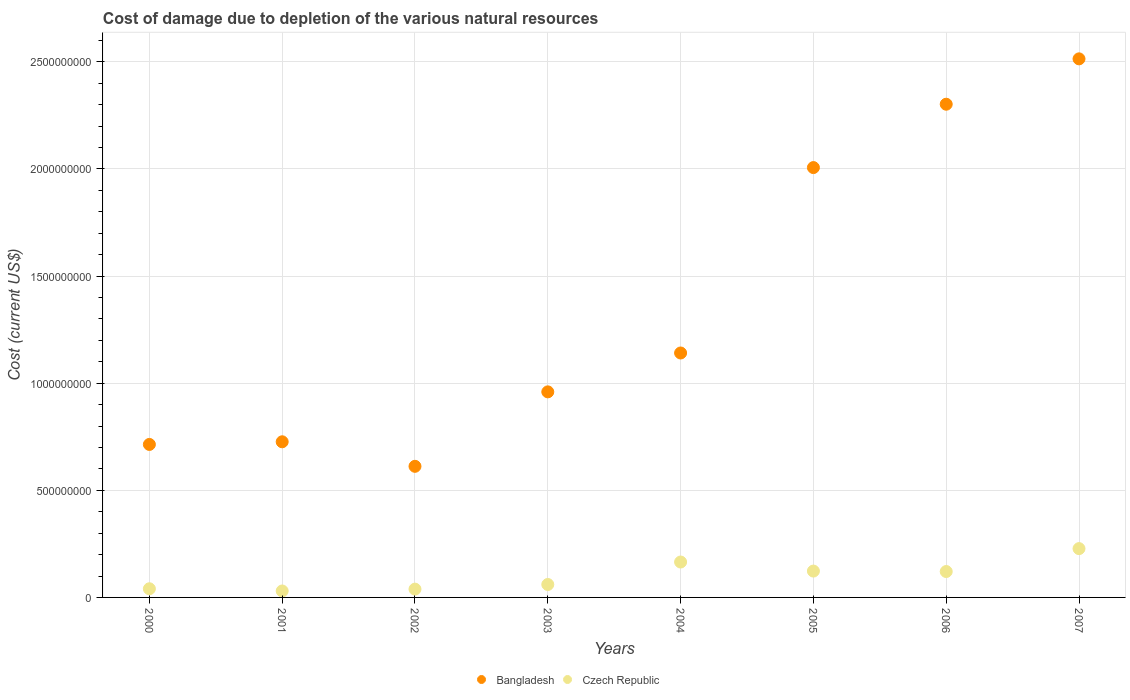Is the number of dotlines equal to the number of legend labels?
Offer a very short reply. Yes. What is the cost of damage caused due to the depletion of various natural resources in Czech Republic in 2006?
Offer a very short reply. 1.21e+08. Across all years, what is the maximum cost of damage caused due to the depletion of various natural resources in Czech Republic?
Give a very brief answer. 2.28e+08. Across all years, what is the minimum cost of damage caused due to the depletion of various natural resources in Czech Republic?
Your response must be concise. 3.01e+07. What is the total cost of damage caused due to the depletion of various natural resources in Bangladesh in the graph?
Offer a terse response. 1.10e+1. What is the difference between the cost of damage caused due to the depletion of various natural resources in Bangladesh in 2006 and that in 2007?
Ensure brevity in your answer.  -2.12e+08. What is the difference between the cost of damage caused due to the depletion of various natural resources in Czech Republic in 2002 and the cost of damage caused due to the depletion of various natural resources in Bangladesh in 2007?
Offer a very short reply. -2.48e+09. What is the average cost of damage caused due to the depletion of various natural resources in Czech Republic per year?
Your answer should be very brief. 1.01e+08. In the year 2007, what is the difference between the cost of damage caused due to the depletion of various natural resources in Czech Republic and cost of damage caused due to the depletion of various natural resources in Bangladesh?
Keep it short and to the point. -2.29e+09. What is the ratio of the cost of damage caused due to the depletion of various natural resources in Bangladesh in 2001 to that in 2002?
Your answer should be very brief. 1.19. Is the difference between the cost of damage caused due to the depletion of various natural resources in Czech Republic in 2002 and 2006 greater than the difference between the cost of damage caused due to the depletion of various natural resources in Bangladesh in 2002 and 2006?
Your response must be concise. Yes. What is the difference between the highest and the second highest cost of damage caused due to the depletion of various natural resources in Bangladesh?
Offer a very short reply. 2.12e+08. What is the difference between the highest and the lowest cost of damage caused due to the depletion of various natural resources in Czech Republic?
Your answer should be compact. 1.98e+08. In how many years, is the cost of damage caused due to the depletion of various natural resources in Czech Republic greater than the average cost of damage caused due to the depletion of various natural resources in Czech Republic taken over all years?
Ensure brevity in your answer.  4. Does the cost of damage caused due to the depletion of various natural resources in Czech Republic monotonically increase over the years?
Keep it short and to the point. No. Is the cost of damage caused due to the depletion of various natural resources in Bangladesh strictly greater than the cost of damage caused due to the depletion of various natural resources in Czech Republic over the years?
Your answer should be compact. Yes. What is the difference between two consecutive major ticks on the Y-axis?
Make the answer very short. 5.00e+08. Are the values on the major ticks of Y-axis written in scientific E-notation?
Provide a succinct answer. No. Does the graph contain any zero values?
Provide a succinct answer. No. Does the graph contain grids?
Offer a very short reply. Yes. How are the legend labels stacked?
Offer a terse response. Horizontal. What is the title of the graph?
Ensure brevity in your answer.  Cost of damage due to depletion of the various natural resources. What is the label or title of the X-axis?
Provide a succinct answer. Years. What is the label or title of the Y-axis?
Ensure brevity in your answer.  Cost (current US$). What is the Cost (current US$) of Bangladesh in 2000?
Make the answer very short. 7.14e+08. What is the Cost (current US$) of Czech Republic in 2000?
Make the answer very short. 4.04e+07. What is the Cost (current US$) in Bangladesh in 2001?
Offer a terse response. 7.27e+08. What is the Cost (current US$) in Czech Republic in 2001?
Offer a terse response. 3.01e+07. What is the Cost (current US$) in Bangladesh in 2002?
Give a very brief answer. 6.12e+08. What is the Cost (current US$) of Czech Republic in 2002?
Provide a short and direct response. 3.87e+07. What is the Cost (current US$) of Bangladesh in 2003?
Offer a very short reply. 9.60e+08. What is the Cost (current US$) of Czech Republic in 2003?
Offer a terse response. 6.04e+07. What is the Cost (current US$) in Bangladesh in 2004?
Your answer should be very brief. 1.14e+09. What is the Cost (current US$) in Czech Republic in 2004?
Provide a succinct answer. 1.65e+08. What is the Cost (current US$) of Bangladesh in 2005?
Make the answer very short. 2.01e+09. What is the Cost (current US$) of Czech Republic in 2005?
Provide a short and direct response. 1.23e+08. What is the Cost (current US$) in Bangladesh in 2006?
Give a very brief answer. 2.30e+09. What is the Cost (current US$) of Czech Republic in 2006?
Offer a very short reply. 1.21e+08. What is the Cost (current US$) of Bangladesh in 2007?
Give a very brief answer. 2.51e+09. What is the Cost (current US$) of Czech Republic in 2007?
Offer a very short reply. 2.28e+08. Across all years, what is the maximum Cost (current US$) in Bangladesh?
Provide a short and direct response. 2.51e+09. Across all years, what is the maximum Cost (current US$) in Czech Republic?
Your answer should be very brief. 2.28e+08. Across all years, what is the minimum Cost (current US$) in Bangladesh?
Give a very brief answer. 6.12e+08. Across all years, what is the minimum Cost (current US$) in Czech Republic?
Your answer should be compact. 3.01e+07. What is the total Cost (current US$) in Bangladesh in the graph?
Ensure brevity in your answer.  1.10e+1. What is the total Cost (current US$) of Czech Republic in the graph?
Give a very brief answer. 8.07e+08. What is the difference between the Cost (current US$) in Bangladesh in 2000 and that in 2001?
Give a very brief answer. -1.23e+07. What is the difference between the Cost (current US$) in Czech Republic in 2000 and that in 2001?
Offer a terse response. 1.03e+07. What is the difference between the Cost (current US$) of Bangladesh in 2000 and that in 2002?
Make the answer very short. 1.02e+08. What is the difference between the Cost (current US$) in Czech Republic in 2000 and that in 2002?
Your answer should be very brief. 1.72e+06. What is the difference between the Cost (current US$) in Bangladesh in 2000 and that in 2003?
Provide a succinct answer. -2.45e+08. What is the difference between the Cost (current US$) of Czech Republic in 2000 and that in 2003?
Provide a short and direct response. -2.00e+07. What is the difference between the Cost (current US$) of Bangladesh in 2000 and that in 2004?
Ensure brevity in your answer.  -4.27e+08. What is the difference between the Cost (current US$) of Czech Republic in 2000 and that in 2004?
Offer a very short reply. -1.25e+08. What is the difference between the Cost (current US$) of Bangladesh in 2000 and that in 2005?
Offer a terse response. -1.29e+09. What is the difference between the Cost (current US$) in Czech Republic in 2000 and that in 2005?
Ensure brevity in your answer.  -8.26e+07. What is the difference between the Cost (current US$) of Bangladesh in 2000 and that in 2006?
Offer a terse response. -1.59e+09. What is the difference between the Cost (current US$) of Czech Republic in 2000 and that in 2006?
Offer a very short reply. -8.05e+07. What is the difference between the Cost (current US$) of Bangladesh in 2000 and that in 2007?
Give a very brief answer. -1.80e+09. What is the difference between the Cost (current US$) in Czech Republic in 2000 and that in 2007?
Your answer should be compact. -1.87e+08. What is the difference between the Cost (current US$) in Bangladesh in 2001 and that in 2002?
Give a very brief answer. 1.15e+08. What is the difference between the Cost (current US$) of Czech Republic in 2001 and that in 2002?
Ensure brevity in your answer.  -8.56e+06. What is the difference between the Cost (current US$) of Bangladesh in 2001 and that in 2003?
Offer a terse response. -2.33e+08. What is the difference between the Cost (current US$) of Czech Republic in 2001 and that in 2003?
Your response must be concise. -3.03e+07. What is the difference between the Cost (current US$) in Bangladesh in 2001 and that in 2004?
Offer a very short reply. -4.15e+08. What is the difference between the Cost (current US$) in Czech Republic in 2001 and that in 2004?
Your answer should be very brief. -1.35e+08. What is the difference between the Cost (current US$) of Bangladesh in 2001 and that in 2005?
Offer a very short reply. -1.28e+09. What is the difference between the Cost (current US$) in Czech Republic in 2001 and that in 2005?
Your response must be concise. -9.29e+07. What is the difference between the Cost (current US$) in Bangladesh in 2001 and that in 2006?
Your answer should be compact. -1.58e+09. What is the difference between the Cost (current US$) in Czech Republic in 2001 and that in 2006?
Your response must be concise. -9.07e+07. What is the difference between the Cost (current US$) in Bangladesh in 2001 and that in 2007?
Provide a short and direct response. -1.79e+09. What is the difference between the Cost (current US$) of Czech Republic in 2001 and that in 2007?
Offer a very short reply. -1.98e+08. What is the difference between the Cost (current US$) of Bangladesh in 2002 and that in 2003?
Provide a short and direct response. -3.48e+08. What is the difference between the Cost (current US$) of Czech Republic in 2002 and that in 2003?
Your answer should be very brief. -2.17e+07. What is the difference between the Cost (current US$) of Bangladesh in 2002 and that in 2004?
Your answer should be compact. -5.29e+08. What is the difference between the Cost (current US$) of Czech Republic in 2002 and that in 2004?
Offer a terse response. -1.27e+08. What is the difference between the Cost (current US$) in Bangladesh in 2002 and that in 2005?
Offer a very short reply. -1.39e+09. What is the difference between the Cost (current US$) in Czech Republic in 2002 and that in 2005?
Offer a terse response. -8.43e+07. What is the difference between the Cost (current US$) in Bangladesh in 2002 and that in 2006?
Make the answer very short. -1.69e+09. What is the difference between the Cost (current US$) in Czech Republic in 2002 and that in 2006?
Your response must be concise. -8.22e+07. What is the difference between the Cost (current US$) of Bangladesh in 2002 and that in 2007?
Your answer should be compact. -1.90e+09. What is the difference between the Cost (current US$) in Czech Republic in 2002 and that in 2007?
Provide a succinct answer. -1.89e+08. What is the difference between the Cost (current US$) of Bangladesh in 2003 and that in 2004?
Give a very brief answer. -1.81e+08. What is the difference between the Cost (current US$) in Czech Republic in 2003 and that in 2004?
Your response must be concise. -1.05e+08. What is the difference between the Cost (current US$) of Bangladesh in 2003 and that in 2005?
Provide a short and direct response. -1.05e+09. What is the difference between the Cost (current US$) in Czech Republic in 2003 and that in 2005?
Offer a very short reply. -6.26e+07. What is the difference between the Cost (current US$) in Bangladesh in 2003 and that in 2006?
Offer a very short reply. -1.34e+09. What is the difference between the Cost (current US$) of Czech Republic in 2003 and that in 2006?
Your answer should be very brief. -6.05e+07. What is the difference between the Cost (current US$) of Bangladesh in 2003 and that in 2007?
Offer a terse response. -1.55e+09. What is the difference between the Cost (current US$) of Czech Republic in 2003 and that in 2007?
Make the answer very short. -1.67e+08. What is the difference between the Cost (current US$) in Bangladesh in 2004 and that in 2005?
Ensure brevity in your answer.  -8.65e+08. What is the difference between the Cost (current US$) of Czech Republic in 2004 and that in 2005?
Provide a succinct answer. 4.23e+07. What is the difference between the Cost (current US$) of Bangladesh in 2004 and that in 2006?
Make the answer very short. -1.16e+09. What is the difference between the Cost (current US$) in Czech Republic in 2004 and that in 2006?
Give a very brief answer. 4.44e+07. What is the difference between the Cost (current US$) in Bangladesh in 2004 and that in 2007?
Your answer should be compact. -1.37e+09. What is the difference between the Cost (current US$) in Czech Republic in 2004 and that in 2007?
Offer a very short reply. -6.26e+07. What is the difference between the Cost (current US$) in Bangladesh in 2005 and that in 2006?
Make the answer very short. -2.96e+08. What is the difference between the Cost (current US$) in Czech Republic in 2005 and that in 2006?
Ensure brevity in your answer.  2.14e+06. What is the difference between the Cost (current US$) of Bangladesh in 2005 and that in 2007?
Provide a short and direct response. -5.08e+08. What is the difference between the Cost (current US$) of Czech Republic in 2005 and that in 2007?
Ensure brevity in your answer.  -1.05e+08. What is the difference between the Cost (current US$) of Bangladesh in 2006 and that in 2007?
Your answer should be very brief. -2.12e+08. What is the difference between the Cost (current US$) in Czech Republic in 2006 and that in 2007?
Give a very brief answer. -1.07e+08. What is the difference between the Cost (current US$) in Bangladesh in 2000 and the Cost (current US$) in Czech Republic in 2001?
Offer a terse response. 6.84e+08. What is the difference between the Cost (current US$) of Bangladesh in 2000 and the Cost (current US$) of Czech Republic in 2002?
Your response must be concise. 6.75e+08. What is the difference between the Cost (current US$) of Bangladesh in 2000 and the Cost (current US$) of Czech Republic in 2003?
Your answer should be very brief. 6.54e+08. What is the difference between the Cost (current US$) of Bangladesh in 2000 and the Cost (current US$) of Czech Republic in 2004?
Give a very brief answer. 5.49e+08. What is the difference between the Cost (current US$) in Bangladesh in 2000 and the Cost (current US$) in Czech Republic in 2005?
Offer a very short reply. 5.91e+08. What is the difference between the Cost (current US$) in Bangladesh in 2000 and the Cost (current US$) in Czech Republic in 2006?
Provide a short and direct response. 5.93e+08. What is the difference between the Cost (current US$) in Bangladesh in 2000 and the Cost (current US$) in Czech Republic in 2007?
Offer a terse response. 4.86e+08. What is the difference between the Cost (current US$) in Bangladesh in 2001 and the Cost (current US$) in Czech Republic in 2002?
Ensure brevity in your answer.  6.88e+08. What is the difference between the Cost (current US$) of Bangladesh in 2001 and the Cost (current US$) of Czech Republic in 2003?
Keep it short and to the point. 6.66e+08. What is the difference between the Cost (current US$) in Bangladesh in 2001 and the Cost (current US$) in Czech Republic in 2004?
Provide a succinct answer. 5.61e+08. What is the difference between the Cost (current US$) in Bangladesh in 2001 and the Cost (current US$) in Czech Republic in 2005?
Offer a terse response. 6.04e+08. What is the difference between the Cost (current US$) in Bangladesh in 2001 and the Cost (current US$) in Czech Republic in 2006?
Offer a very short reply. 6.06e+08. What is the difference between the Cost (current US$) in Bangladesh in 2001 and the Cost (current US$) in Czech Republic in 2007?
Make the answer very short. 4.99e+08. What is the difference between the Cost (current US$) in Bangladesh in 2002 and the Cost (current US$) in Czech Republic in 2003?
Make the answer very short. 5.52e+08. What is the difference between the Cost (current US$) of Bangladesh in 2002 and the Cost (current US$) of Czech Republic in 2004?
Provide a succinct answer. 4.47e+08. What is the difference between the Cost (current US$) of Bangladesh in 2002 and the Cost (current US$) of Czech Republic in 2005?
Give a very brief answer. 4.89e+08. What is the difference between the Cost (current US$) of Bangladesh in 2002 and the Cost (current US$) of Czech Republic in 2006?
Offer a very short reply. 4.91e+08. What is the difference between the Cost (current US$) in Bangladesh in 2002 and the Cost (current US$) in Czech Republic in 2007?
Your response must be concise. 3.84e+08. What is the difference between the Cost (current US$) of Bangladesh in 2003 and the Cost (current US$) of Czech Republic in 2004?
Provide a short and direct response. 7.94e+08. What is the difference between the Cost (current US$) in Bangladesh in 2003 and the Cost (current US$) in Czech Republic in 2005?
Ensure brevity in your answer.  8.37e+08. What is the difference between the Cost (current US$) of Bangladesh in 2003 and the Cost (current US$) of Czech Republic in 2006?
Ensure brevity in your answer.  8.39e+08. What is the difference between the Cost (current US$) in Bangladesh in 2003 and the Cost (current US$) in Czech Republic in 2007?
Offer a terse response. 7.32e+08. What is the difference between the Cost (current US$) of Bangladesh in 2004 and the Cost (current US$) of Czech Republic in 2005?
Your answer should be very brief. 1.02e+09. What is the difference between the Cost (current US$) in Bangladesh in 2004 and the Cost (current US$) in Czech Republic in 2006?
Make the answer very short. 1.02e+09. What is the difference between the Cost (current US$) of Bangladesh in 2004 and the Cost (current US$) of Czech Republic in 2007?
Offer a terse response. 9.13e+08. What is the difference between the Cost (current US$) of Bangladesh in 2005 and the Cost (current US$) of Czech Republic in 2006?
Make the answer very short. 1.89e+09. What is the difference between the Cost (current US$) in Bangladesh in 2005 and the Cost (current US$) in Czech Republic in 2007?
Offer a very short reply. 1.78e+09. What is the difference between the Cost (current US$) in Bangladesh in 2006 and the Cost (current US$) in Czech Republic in 2007?
Your response must be concise. 2.07e+09. What is the average Cost (current US$) in Bangladesh per year?
Your answer should be very brief. 1.37e+09. What is the average Cost (current US$) of Czech Republic per year?
Your response must be concise. 1.01e+08. In the year 2000, what is the difference between the Cost (current US$) in Bangladesh and Cost (current US$) in Czech Republic?
Offer a terse response. 6.74e+08. In the year 2001, what is the difference between the Cost (current US$) in Bangladesh and Cost (current US$) in Czech Republic?
Give a very brief answer. 6.96e+08. In the year 2002, what is the difference between the Cost (current US$) in Bangladesh and Cost (current US$) in Czech Republic?
Your answer should be compact. 5.73e+08. In the year 2003, what is the difference between the Cost (current US$) in Bangladesh and Cost (current US$) in Czech Republic?
Ensure brevity in your answer.  8.99e+08. In the year 2004, what is the difference between the Cost (current US$) in Bangladesh and Cost (current US$) in Czech Republic?
Make the answer very short. 9.76e+08. In the year 2005, what is the difference between the Cost (current US$) in Bangladesh and Cost (current US$) in Czech Republic?
Make the answer very short. 1.88e+09. In the year 2006, what is the difference between the Cost (current US$) of Bangladesh and Cost (current US$) of Czech Republic?
Your answer should be very brief. 2.18e+09. In the year 2007, what is the difference between the Cost (current US$) of Bangladesh and Cost (current US$) of Czech Republic?
Provide a succinct answer. 2.29e+09. What is the ratio of the Cost (current US$) in Czech Republic in 2000 to that in 2001?
Offer a terse response. 1.34. What is the ratio of the Cost (current US$) in Bangladesh in 2000 to that in 2002?
Your answer should be compact. 1.17. What is the ratio of the Cost (current US$) of Czech Republic in 2000 to that in 2002?
Provide a short and direct response. 1.04. What is the ratio of the Cost (current US$) of Bangladesh in 2000 to that in 2003?
Provide a succinct answer. 0.74. What is the ratio of the Cost (current US$) in Czech Republic in 2000 to that in 2003?
Give a very brief answer. 0.67. What is the ratio of the Cost (current US$) of Bangladesh in 2000 to that in 2004?
Offer a very short reply. 0.63. What is the ratio of the Cost (current US$) in Czech Republic in 2000 to that in 2004?
Ensure brevity in your answer.  0.24. What is the ratio of the Cost (current US$) in Bangladesh in 2000 to that in 2005?
Offer a very short reply. 0.36. What is the ratio of the Cost (current US$) in Czech Republic in 2000 to that in 2005?
Keep it short and to the point. 0.33. What is the ratio of the Cost (current US$) in Bangladesh in 2000 to that in 2006?
Your response must be concise. 0.31. What is the ratio of the Cost (current US$) of Czech Republic in 2000 to that in 2006?
Make the answer very short. 0.33. What is the ratio of the Cost (current US$) of Bangladesh in 2000 to that in 2007?
Your response must be concise. 0.28. What is the ratio of the Cost (current US$) in Czech Republic in 2000 to that in 2007?
Offer a very short reply. 0.18. What is the ratio of the Cost (current US$) in Bangladesh in 2001 to that in 2002?
Ensure brevity in your answer.  1.19. What is the ratio of the Cost (current US$) of Czech Republic in 2001 to that in 2002?
Offer a terse response. 0.78. What is the ratio of the Cost (current US$) in Bangladesh in 2001 to that in 2003?
Give a very brief answer. 0.76. What is the ratio of the Cost (current US$) in Czech Republic in 2001 to that in 2003?
Ensure brevity in your answer.  0.5. What is the ratio of the Cost (current US$) of Bangladesh in 2001 to that in 2004?
Offer a terse response. 0.64. What is the ratio of the Cost (current US$) in Czech Republic in 2001 to that in 2004?
Provide a short and direct response. 0.18. What is the ratio of the Cost (current US$) in Bangladesh in 2001 to that in 2005?
Make the answer very short. 0.36. What is the ratio of the Cost (current US$) in Czech Republic in 2001 to that in 2005?
Offer a terse response. 0.24. What is the ratio of the Cost (current US$) in Bangladesh in 2001 to that in 2006?
Offer a very short reply. 0.32. What is the ratio of the Cost (current US$) in Czech Republic in 2001 to that in 2006?
Your response must be concise. 0.25. What is the ratio of the Cost (current US$) of Bangladesh in 2001 to that in 2007?
Your answer should be compact. 0.29. What is the ratio of the Cost (current US$) in Czech Republic in 2001 to that in 2007?
Provide a short and direct response. 0.13. What is the ratio of the Cost (current US$) in Bangladesh in 2002 to that in 2003?
Your response must be concise. 0.64. What is the ratio of the Cost (current US$) of Czech Republic in 2002 to that in 2003?
Make the answer very short. 0.64. What is the ratio of the Cost (current US$) of Bangladesh in 2002 to that in 2004?
Give a very brief answer. 0.54. What is the ratio of the Cost (current US$) in Czech Republic in 2002 to that in 2004?
Ensure brevity in your answer.  0.23. What is the ratio of the Cost (current US$) of Bangladesh in 2002 to that in 2005?
Your answer should be very brief. 0.3. What is the ratio of the Cost (current US$) of Czech Republic in 2002 to that in 2005?
Your answer should be compact. 0.31. What is the ratio of the Cost (current US$) of Bangladesh in 2002 to that in 2006?
Keep it short and to the point. 0.27. What is the ratio of the Cost (current US$) in Czech Republic in 2002 to that in 2006?
Provide a succinct answer. 0.32. What is the ratio of the Cost (current US$) of Bangladesh in 2002 to that in 2007?
Your answer should be compact. 0.24. What is the ratio of the Cost (current US$) of Czech Republic in 2002 to that in 2007?
Give a very brief answer. 0.17. What is the ratio of the Cost (current US$) of Bangladesh in 2003 to that in 2004?
Provide a short and direct response. 0.84. What is the ratio of the Cost (current US$) in Czech Republic in 2003 to that in 2004?
Give a very brief answer. 0.37. What is the ratio of the Cost (current US$) in Bangladesh in 2003 to that in 2005?
Keep it short and to the point. 0.48. What is the ratio of the Cost (current US$) in Czech Republic in 2003 to that in 2005?
Make the answer very short. 0.49. What is the ratio of the Cost (current US$) in Bangladesh in 2003 to that in 2006?
Offer a terse response. 0.42. What is the ratio of the Cost (current US$) of Czech Republic in 2003 to that in 2006?
Offer a very short reply. 0.5. What is the ratio of the Cost (current US$) in Bangladesh in 2003 to that in 2007?
Provide a short and direct response. 0.38. What is the ratio of the Cost (current US$) in Czech Republic in 2003 to that in 2007?
Make the answer very short. 0.27. What is the ratio of the Cost (current US$) of Bangladesh in 2004 to that in 2005?
Provide a short and direct response. 0.57. What is the ratio of the Cost (current US$) of Czech Republic in 2004 to that in 2005?
Your answer should be compact. 1.34. What is the ratio of the Cost (current US$) in Bangladesh in 2004 to that in 2006?
Provide a succinct answer. 0.5. What is the ratio of the Cost (current US$) in Czech Republic in 2004 to that in 2006?
Your answer should be compact. 1.37. What is the ratio of the Cost (current US$) in Bangladesh in 2004 to that in 2007?
Make the answer very short. 0.45. What is the ratio of the Cost (current US$) in Czech Republic in 2004 to that in 2007?
Provide a succinct answer. 0.73. What is the ratio of the Cost (current US$) of Bangladesh in 2005 to that in 2006?
Provide a succinct answer. 0.87. What is the ratio of the Cost (current US$) in Czech Republic in 2005 to that in 2006?
Make the answer very short. 1.02. What is the ratio of the Cost (current US$) in Bangladesh in 2005 to that in 2007?
Offer a very short reply. 0.8. What is the ratio of the Cost (current US$) of Czech Republic in 2005 to that in 2007?
Offer a very short reply. 0.54. What is the ratio of the Cost (current US$) in Bangladesh in 2006 to that in 2007?
Your response must be concise. 0.92. What is the ratio of the Cost (current US$) in Czech Republic in 2006 to that in 2007?
Offer a very short reply. 0.53. What is the difference between the highest and the second highest Cost (current US$) in Bangladesh?
Give a very brief answer. 2.12e+08. What is the difference between the highest and the second highest Cost (current US$) in Czech Republic?
Ensure brevity in your answer.  6.26e+07. What is the difference between the highest and the lowest Cost (current US$) of Bangladesh?
Your answer should be very brief. 1.90e+09. What is the difference between the highest and the lowest Cost (current US$) of Czech Republic?
Provide a short and direct response. 1.98e+08. 